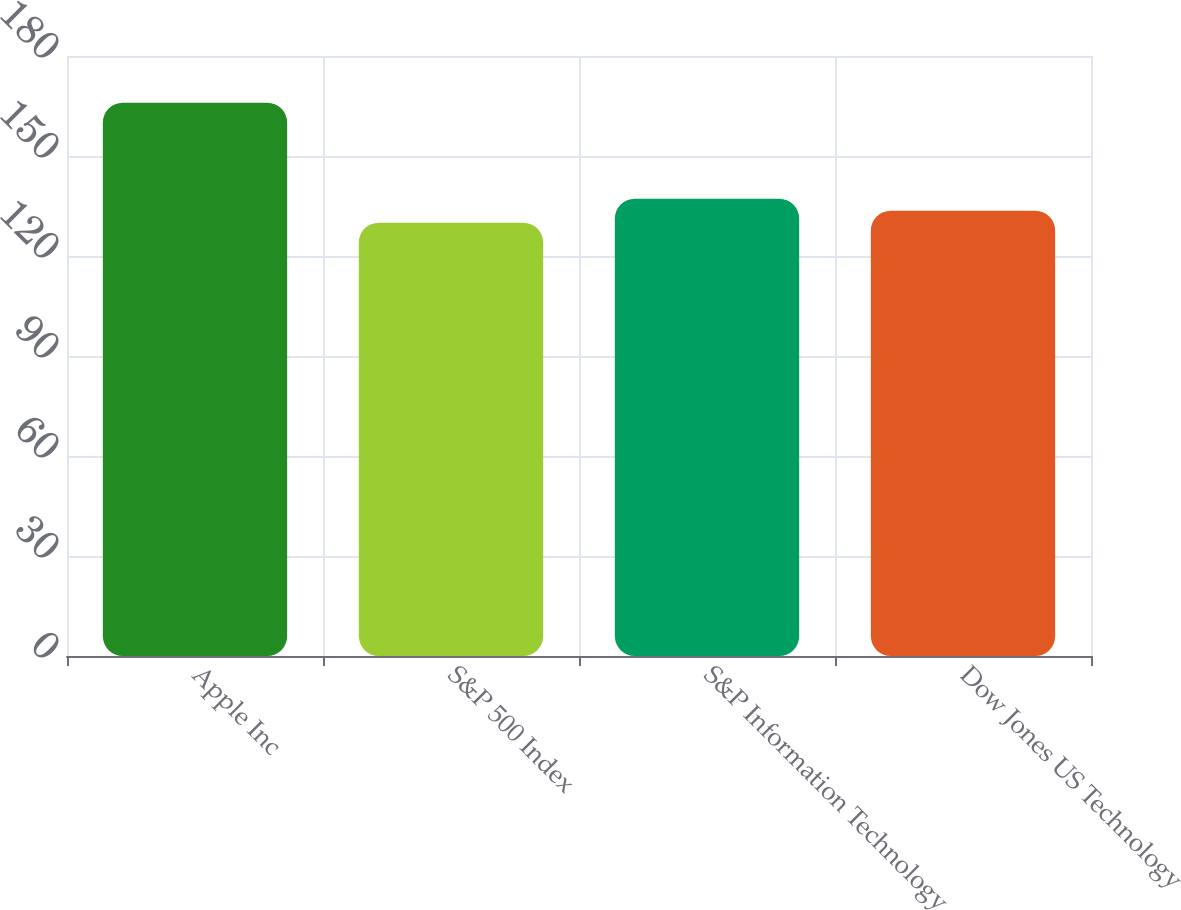Convert chart to OTSL. <chart><loc_0><loc_0><loc_500><loc_500><bar_chart><fcel>Apple Inc<fcel>S&P 500 Index<fcel>S&P Information Technology<fcel>Dow Jones US Technology<nl><fcel>166<fcel>130<fcel>137.2<fcel>133.6<nl></chart> 